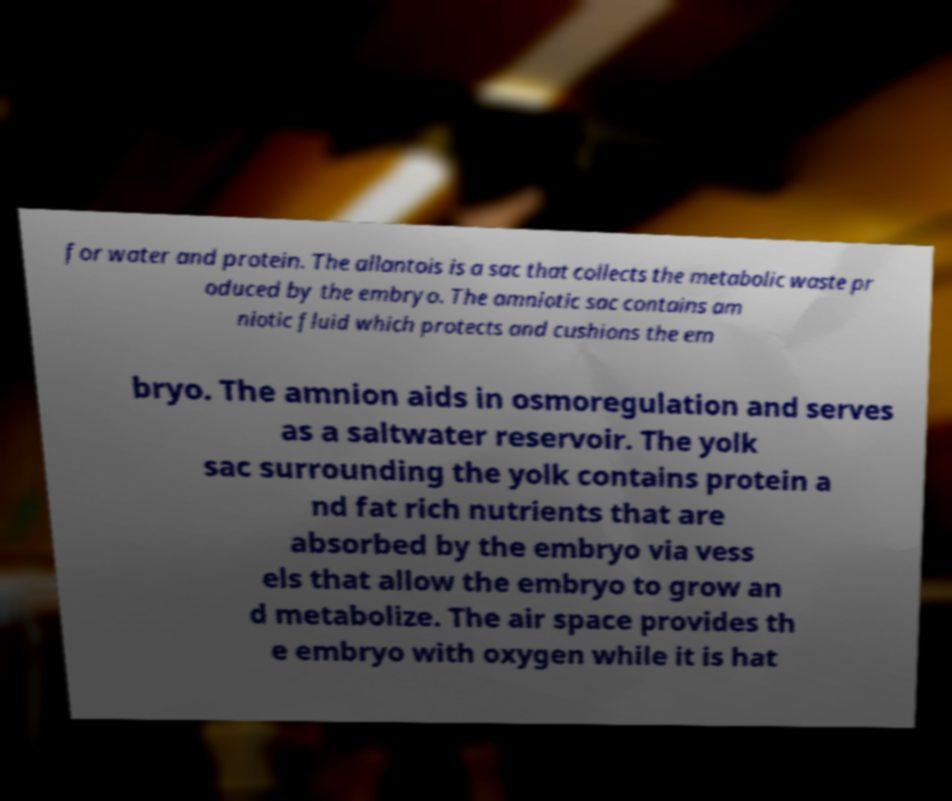I need the written content from this picture converted into text. Can you do that? for water and protein. The allantois is a sac that collects the metabolic waste pr oduced by the embryo. The amniotic sac contains am niotic fluid which protects and cushions the em bryo. The amnion aids in osmoregulation and serves as a saltwater reservoir. The yolk sac surrounding the yolk contains protein a nd fat rich nutrients that are absorbed by the embryo via vess els that allow the embryo to grow an d metabolize. The air space provides th e embryo with oxygen while it is hat 